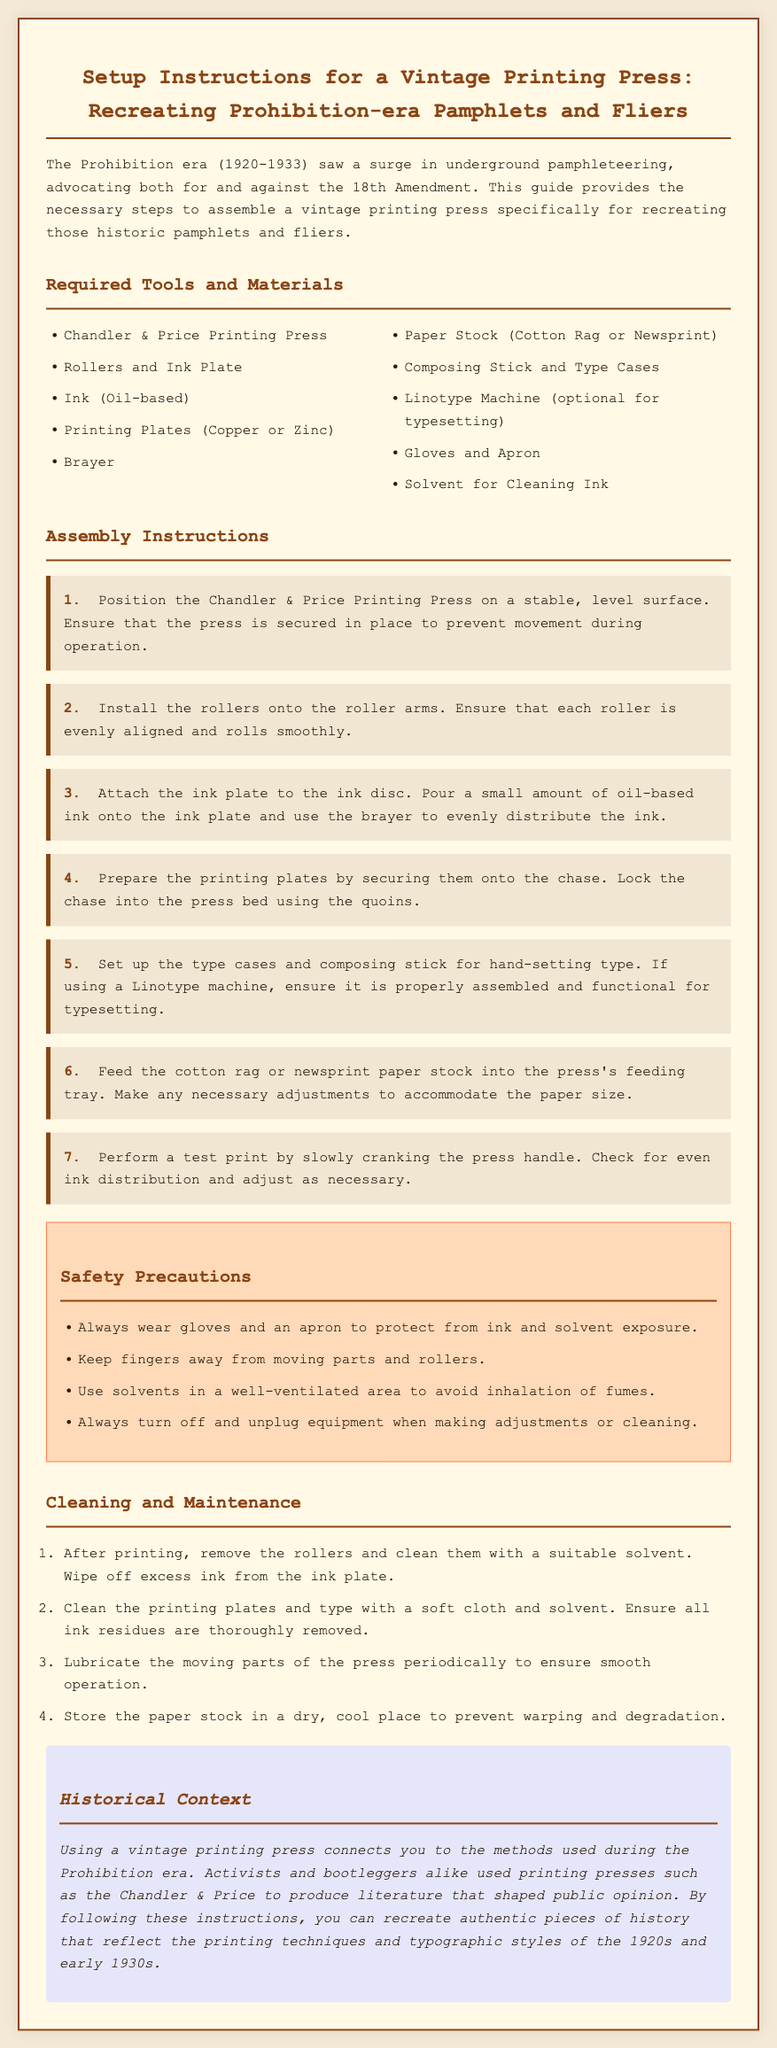What is the main purpose of this guide? The guide provides the necessary steps to assemble a vintage printing press specifically for recreating historic pamphlets and fliers.
Answer: Recreating historic pamphlets and fliers What type of ink is recommended? The document specifies that oil-based ink should be used for the printing process.
Answer: Oil-based ink How many assembly steps are there in total? The instructions enumerate seven distinct assembly steps for setting up the printing press.
Answer: Seven What safety equipment should be worn? The guide emphasizes wearing gloves and an apron to protect against ink and solvent exposure.
Answer: Gloves and apron What is the fourth step in the assembly instructions? The fourth step mentions preparing the printing plates by securing them onto the chase and locking the chase into the press bed using the quoins.
Answer: Prepare the printing plates by securing them onto the chase What should be done after printing? The cleaning and maintenance section highlights that rollers must be removed and cleaned with a suitable solvent after printing is completed.
Answer: Clean rollers with solvent What is a historical significance of using this printing press? The document states that printing presses were used during the Prohibition era to produce literature that shaped public opinion.
Answer: Produce literature that shaped public opinion What type of paper stock is recommended? The assembly instructions recommend using either cotton rag or newsprint for the printing process.
Answer: Cotton rag or newsprint What maintenance step involves lubrication? Lubricating the moving parts of the press periodically is suggested for maintaining smooth operation.
Answer: Lubricate moving parts 